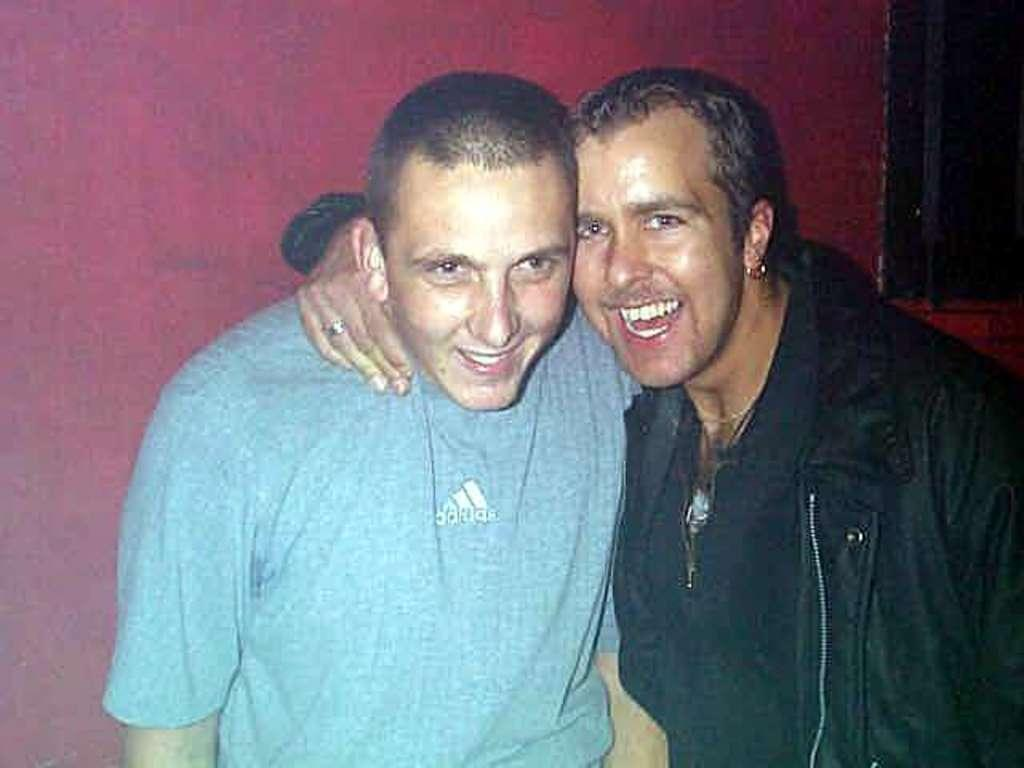How many people are in the image? There are two persons in the image. What is the facial expression of the persons in the image? The persons are smiling. Can you describe the background of the image? There is a black color object on the right side of the image. Can you tell me how many bees are buzzing around the persons in the image? There are no bees present in the image. What is the temperature in the image? The provided facts do not give any information about the temperature in the image. 